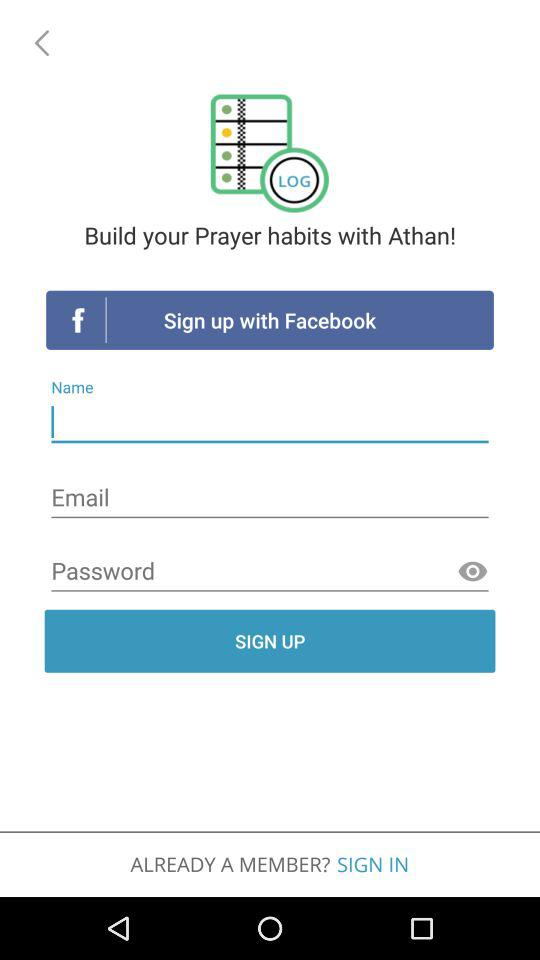How many input fields are there for signing up?
Answer the question using a single word or phrase. 3 